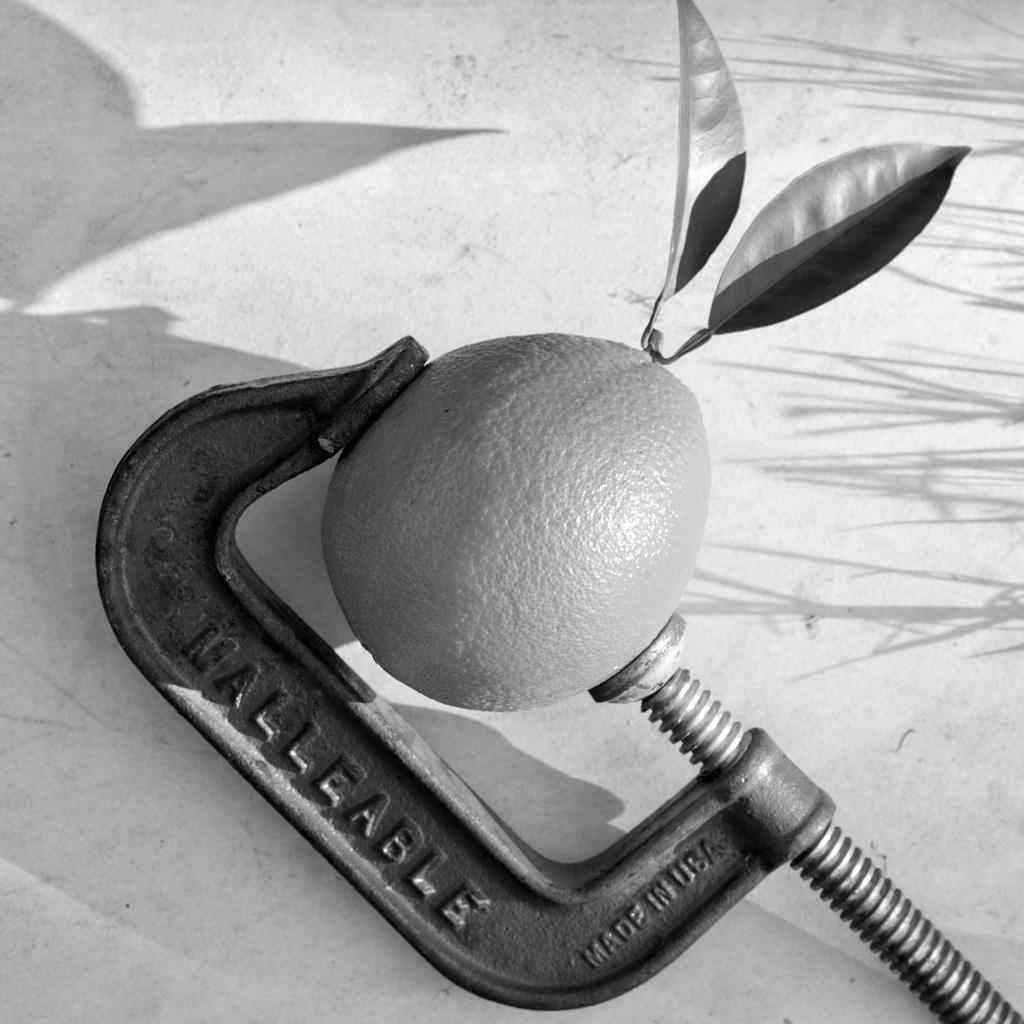<image>
Describe the image concisely. Malleable that is Made in the USA that is squeezing a orange 